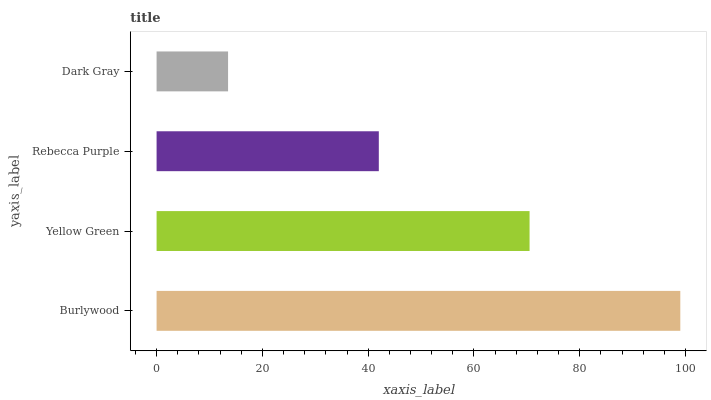Is Dark Gray the minimum?
Answer yes or no. Yes. Is Burlywood the maximum?
Answer yes or no. Yes. Is Yellow Green the minimum?
Answer yes or no. No. Is Yellow Green the maximum?
Answer yes or no. No. Is Burlywood greater than Yellow Green?
Answer yes or no. Yes. Is Yellow Green less than Burlywood?
Answer yes or no. Yes. Is Yellow Green greater than Burlywood?
Answer yes or no. No. Is Burlywood less than Yellow Green?
Answer yes or no. No. Is Yellow Green the high median?
Answer yes or no. Yes. Is Rebecca Purple the low median?
Answer yes or no. Yes. Is Rebecca Purple the high median?
Answer yes or no. No. Is Yellow Green the low median?
Answer yes or no. No. 